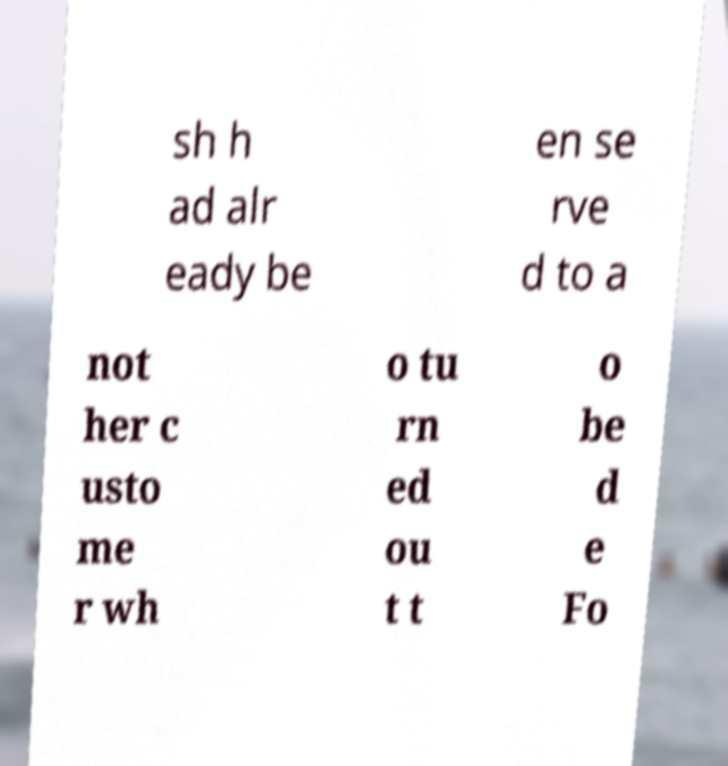I need the written content from this picture converted into text. Can you do that? sh h ad alr eady be en se rve d to a not her c usto me r wh o tu rn ed ou t t o be d e Fo 